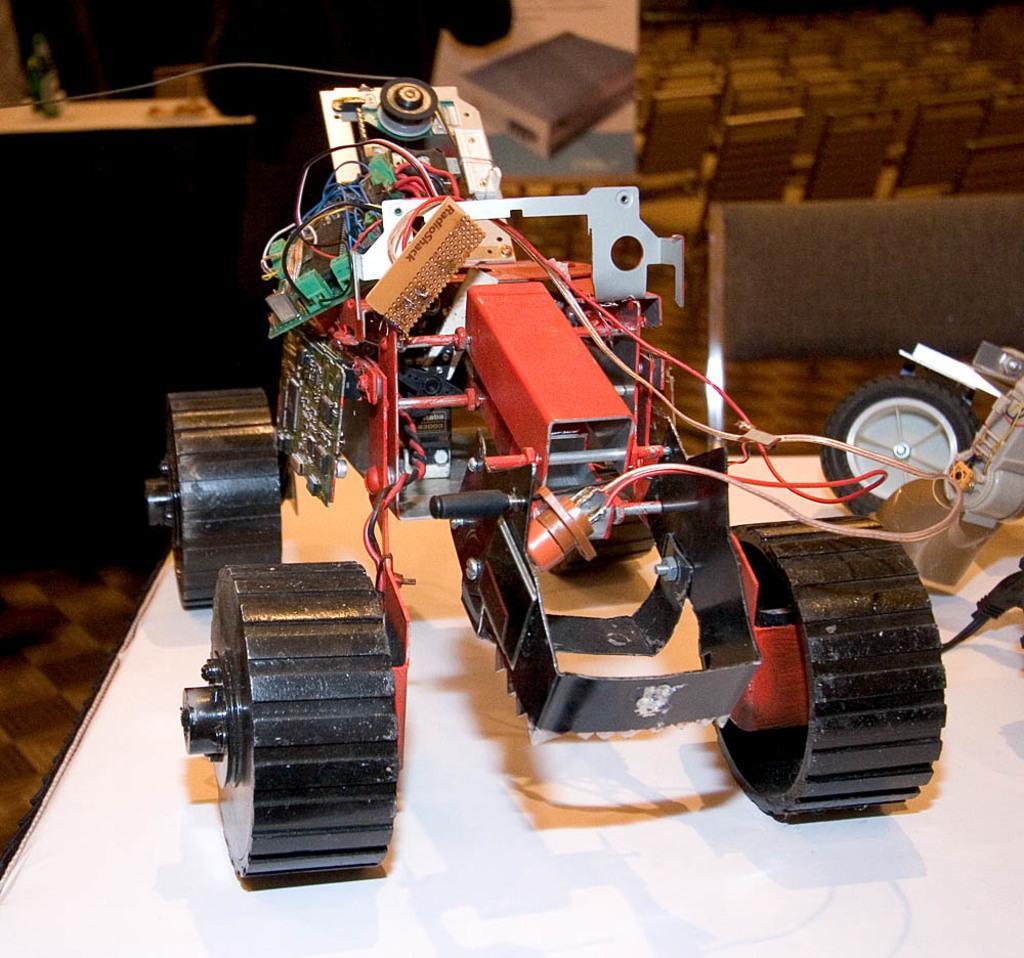Could you give a brief overview of what you see in this image? In this image we can see a toy truck made with wires and some devices which is placed on the surface. On the backside we can see some chairs, objects on a table and a person standing. 